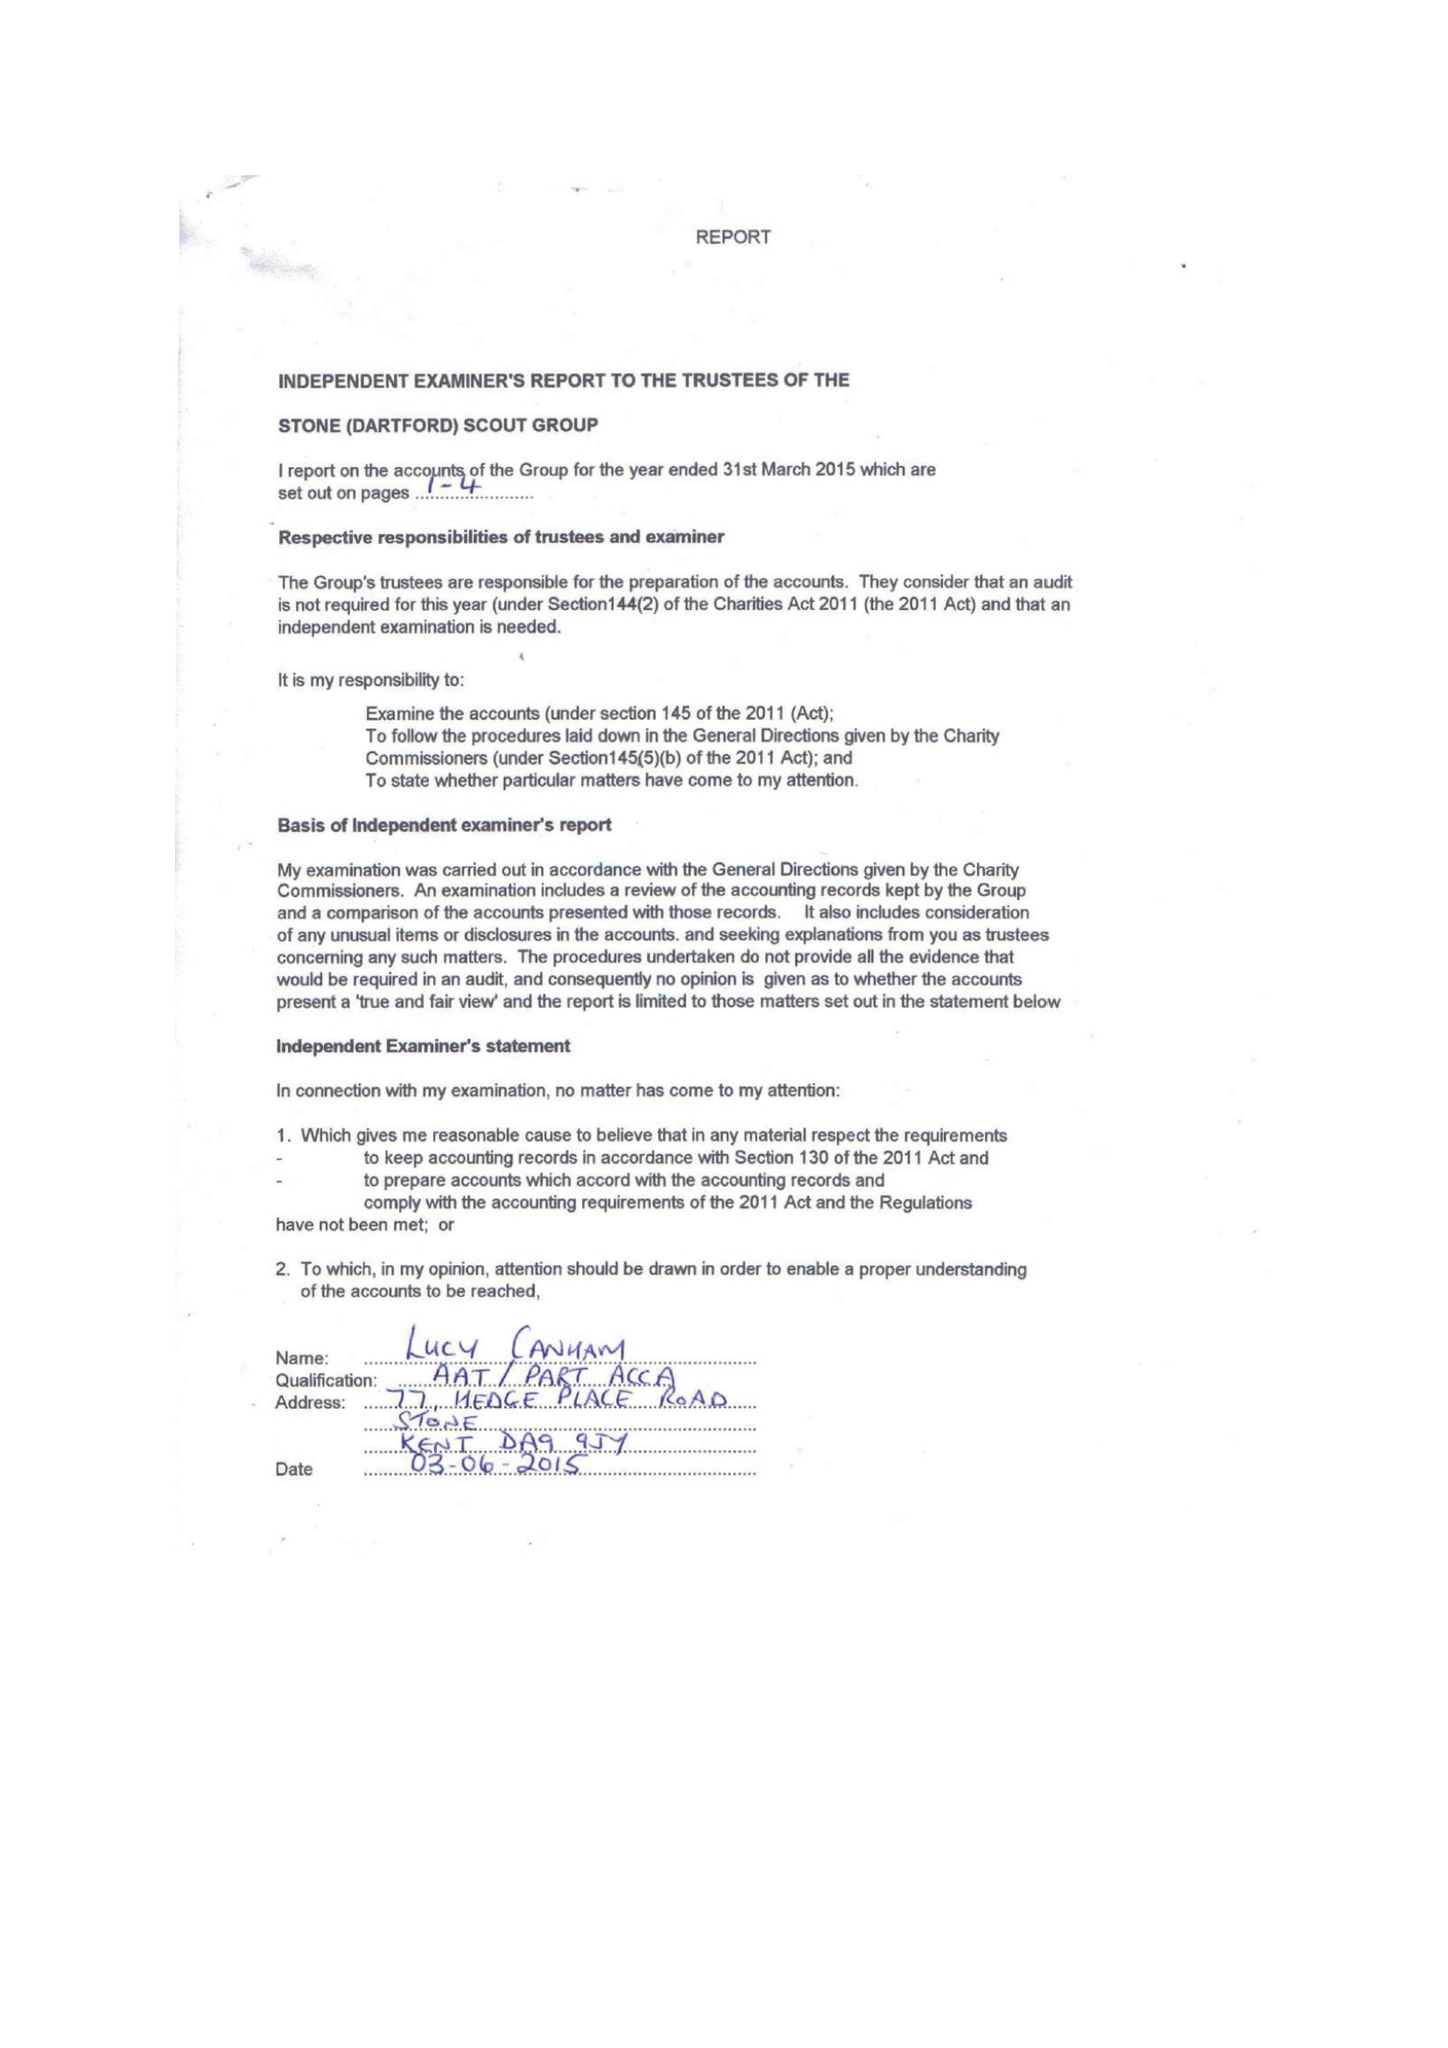What is the value for the report_date?
Answer the question using a single word or phrase. 2015-03-31 